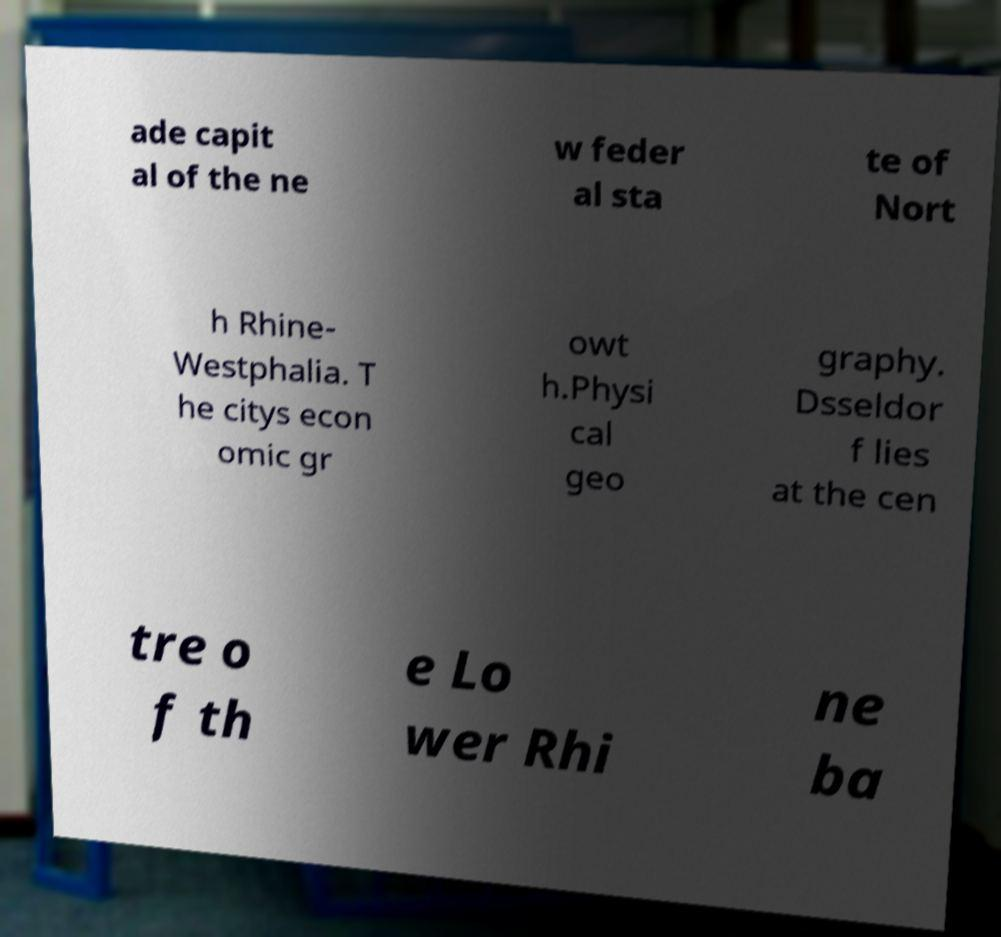Can you accurately transcribe the text from the provided image for me? ade capit al of the ne w feder al sta te of Nort h Rhine- Westphalia. T he citys econ omic gr owt h.Physi cal geo graphy. Dsseldor f lies at the cen tre o f th e Lo wer Rhi ne ba 